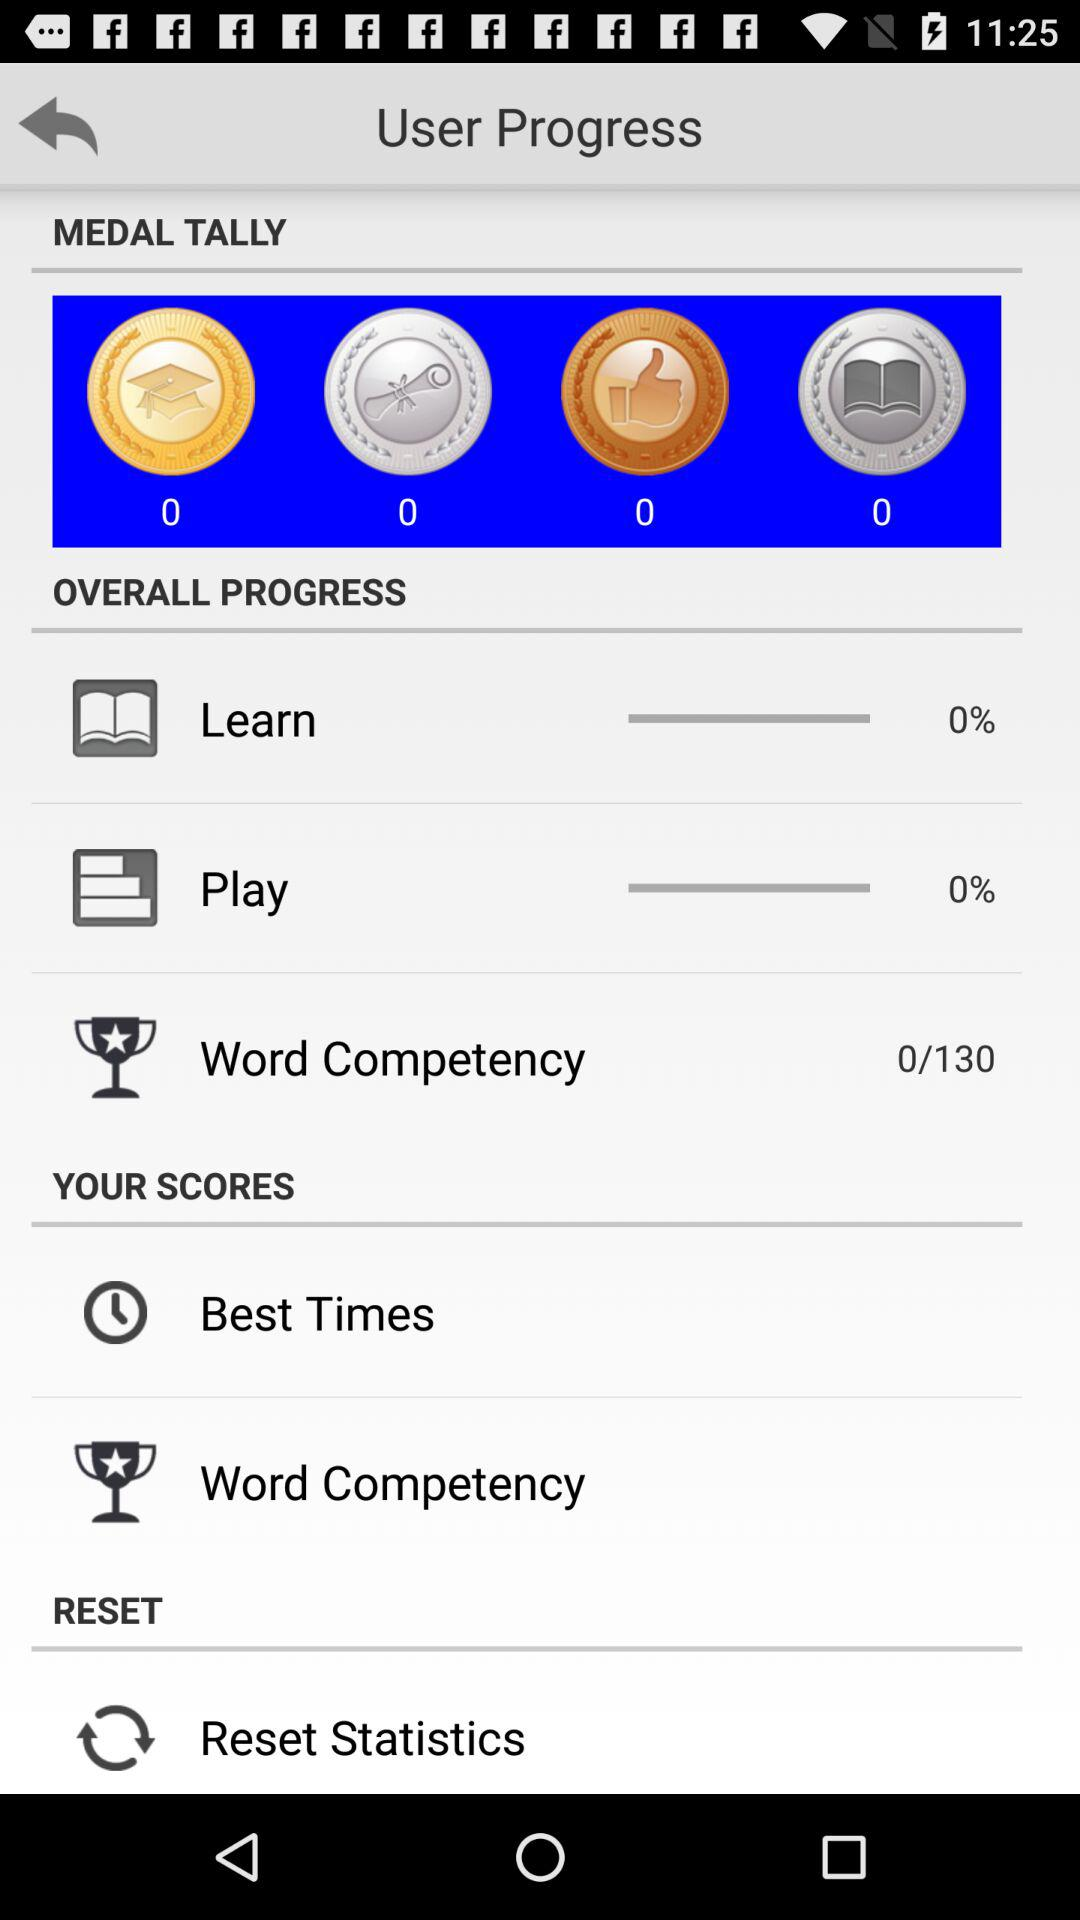How many words are there in "Word Competency"? There are 130 words in "Word Competency". 